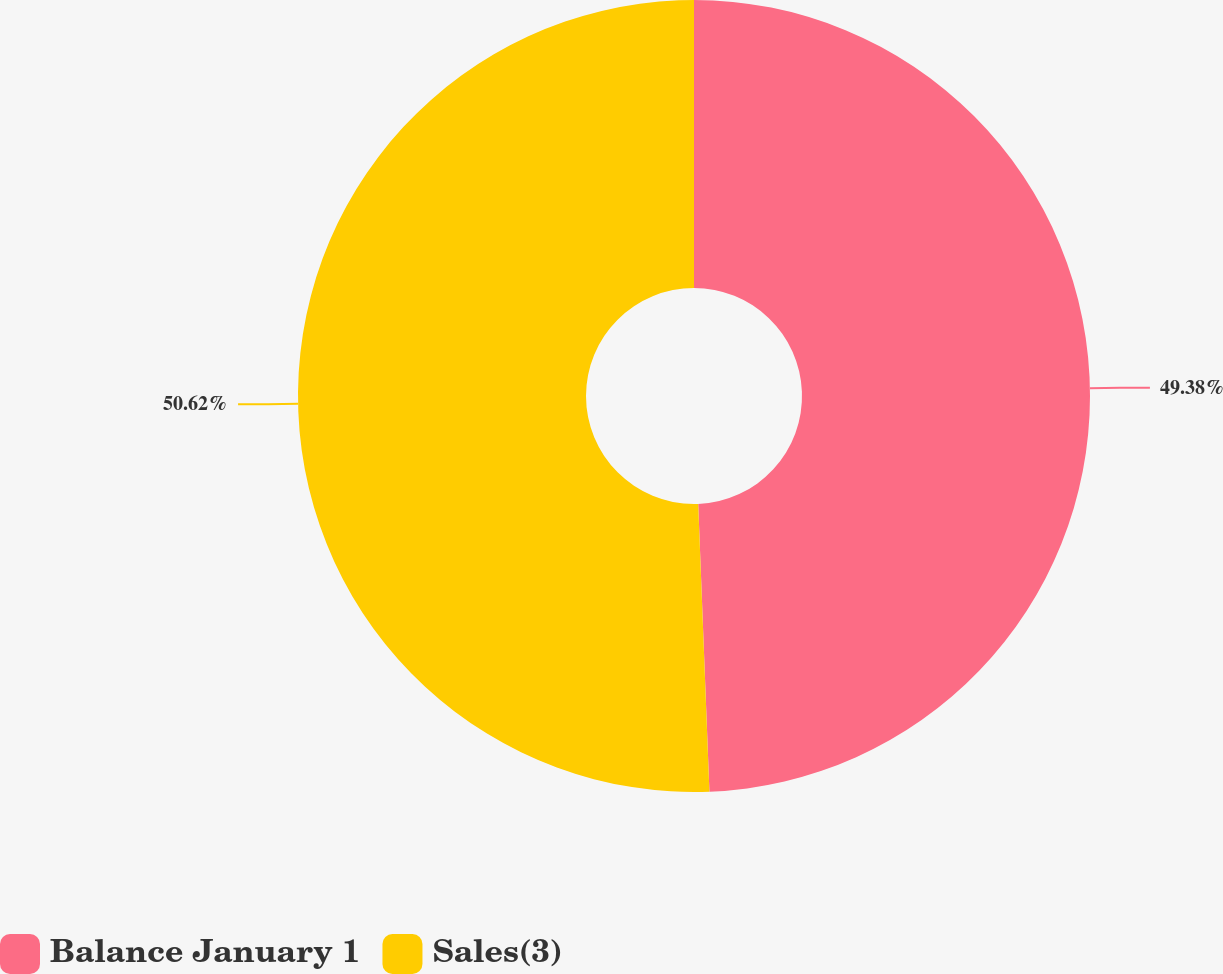Convert chart. <chart><loc_0><loc_0><loc_500><loc_500><pie_chart><fcel>Balance January 1<fcel>Sales(3)<nl><fcel>49.38%<fcel>50.62%<nl></chart> 